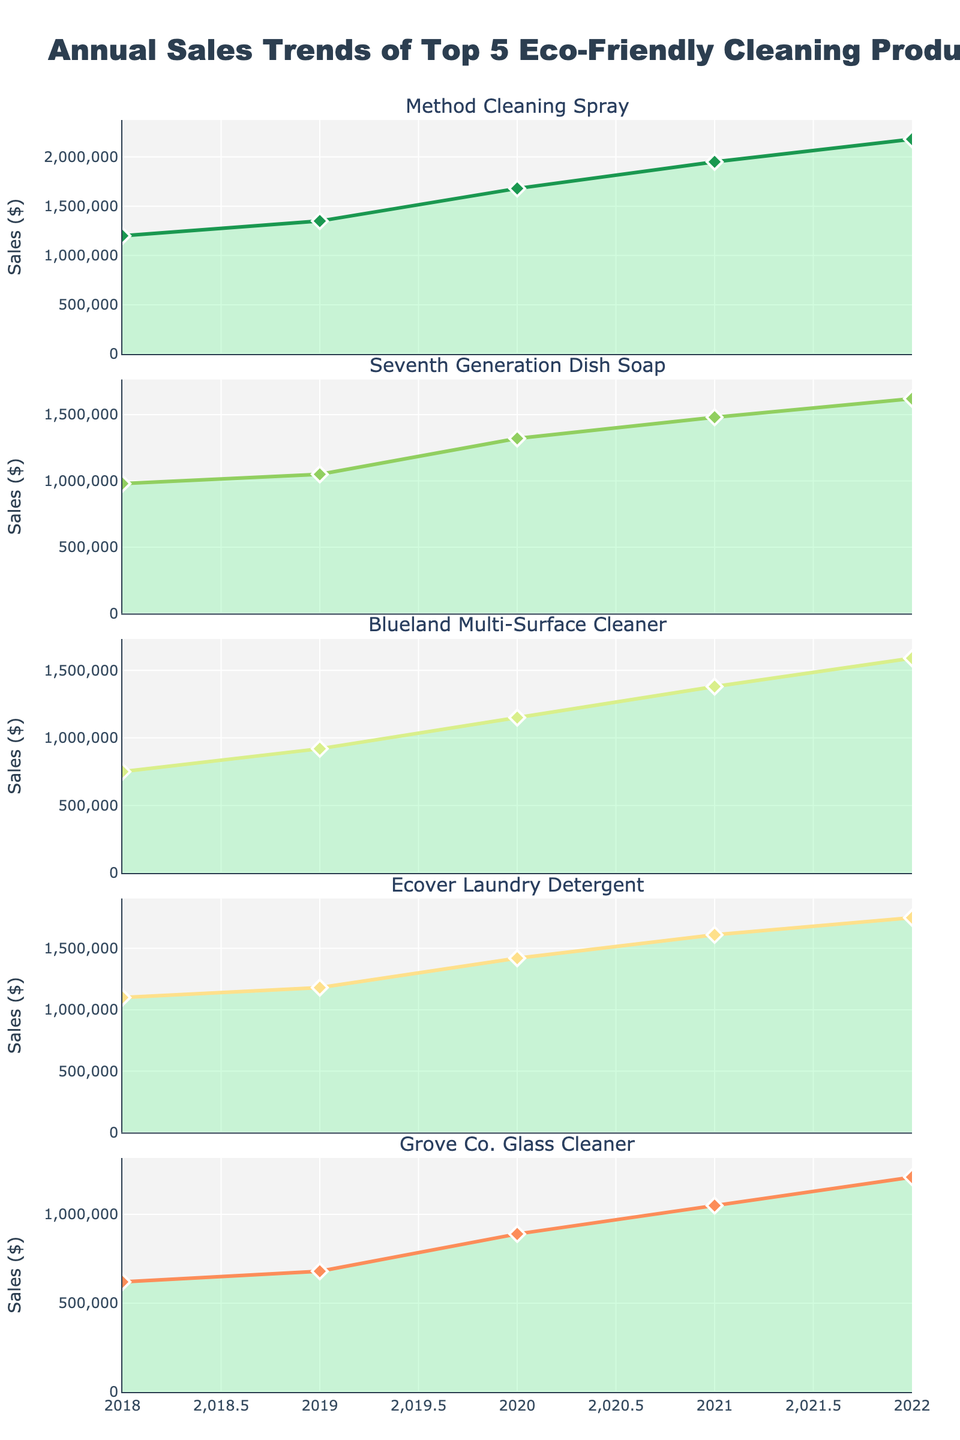what is the range of years displayed on the figure? The figure shows the allocation of charity funds from 2018 to 2022. The x-axis represents these years horizontally.
Answer: 2018 to 2022 What is the title of the figure? The title is at the top of the figure and it indicates what the plot is about.
Answer: Allocation of Charity Funds Across Child Welfare Initiatives (2018-2022) What funding category saw the largest increase from 2018 to 2020? By comparing the bar lengths for each category from 2018 to 2020, Healthcare increased the most (from 28% in 2018 to 35% in 2020).
Answer: Healthcare Which category received the least funding consistently over all five years? By examining the bar lengths across all subplots, Mental Health consistently received the lowest funding, close to 7-8% each year.
Answer: Mental Health What is the largest percentage of funds allocated to Education in any given year? The longest bar in the Education subplot represents the maximum funding allocation, which occurs in 2022 with 33%.
Answer: 33% What is the difference in funding percentage for Nutrition between 2018 and 2019? By comparing the bars for Nutrition in 2018 (15%) and 2019 (16%), the difference is calculated as 16 - 15.
Answer: 1% What was the overall trend of Child Protection funds from 2018 to 2022? By observing the bar lengths for Child Protection across the years, the trend shows a steady decrease from 18% in 2018 to 14% in 2022.
Answer: Decreasing Comparing 2021, which category saw a higher allocation: Healthcare or Education? By comparing the bars for Healthcare (32%) and Education (31%) in 2021, Healthcare had a higher allocation.
Answer: Healthcare Which category experienced the most stability in funding allocation over the 5 years? Mental Health shows consistent values close to 7-8% across all five years, indicating the most stable funding.
Answer: Mental Health What year had the highest combined allocation for Education and Healthcare? Summing the percentages for Education and Healthcare for each year and comparing them, the year with the highest combined allocation (35% + 28%) is 2020.
Answer: 2020 